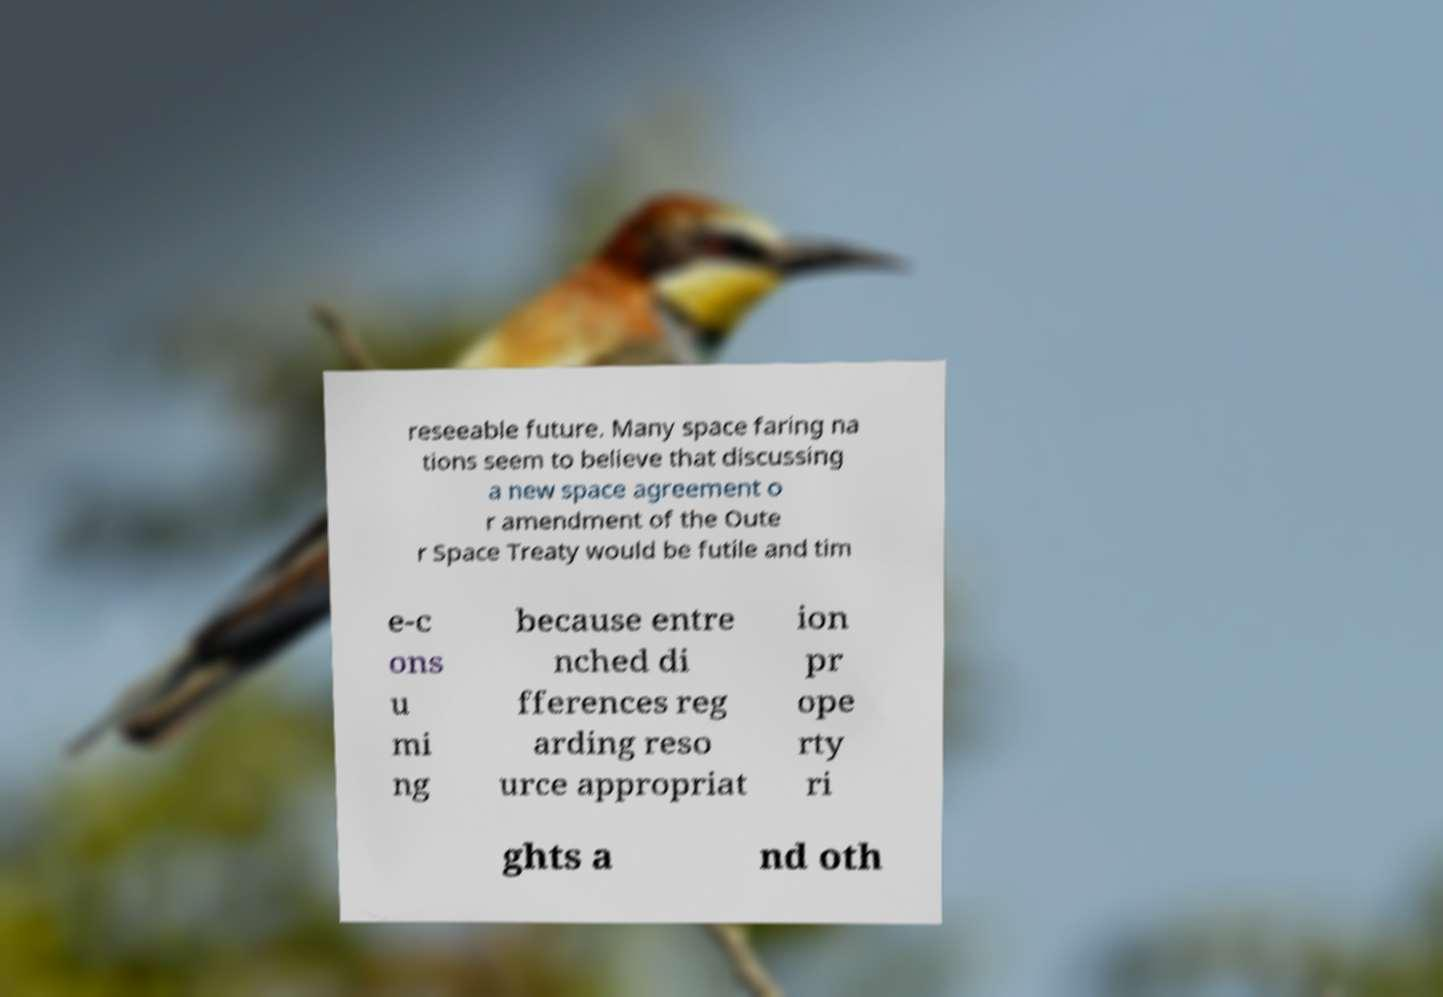What messages or text are displayed in this image? I need them in a readable, typed format. reseeable future. Many space faring na tions seem to believe that discussing a new space agreement o r amendment of the Oute r Space Treaty would be futile and tim e-c ons u mi ng because entre nched di fferences reg arding reso urce appropriat ion pr ope rty ri ghts a nd oth 